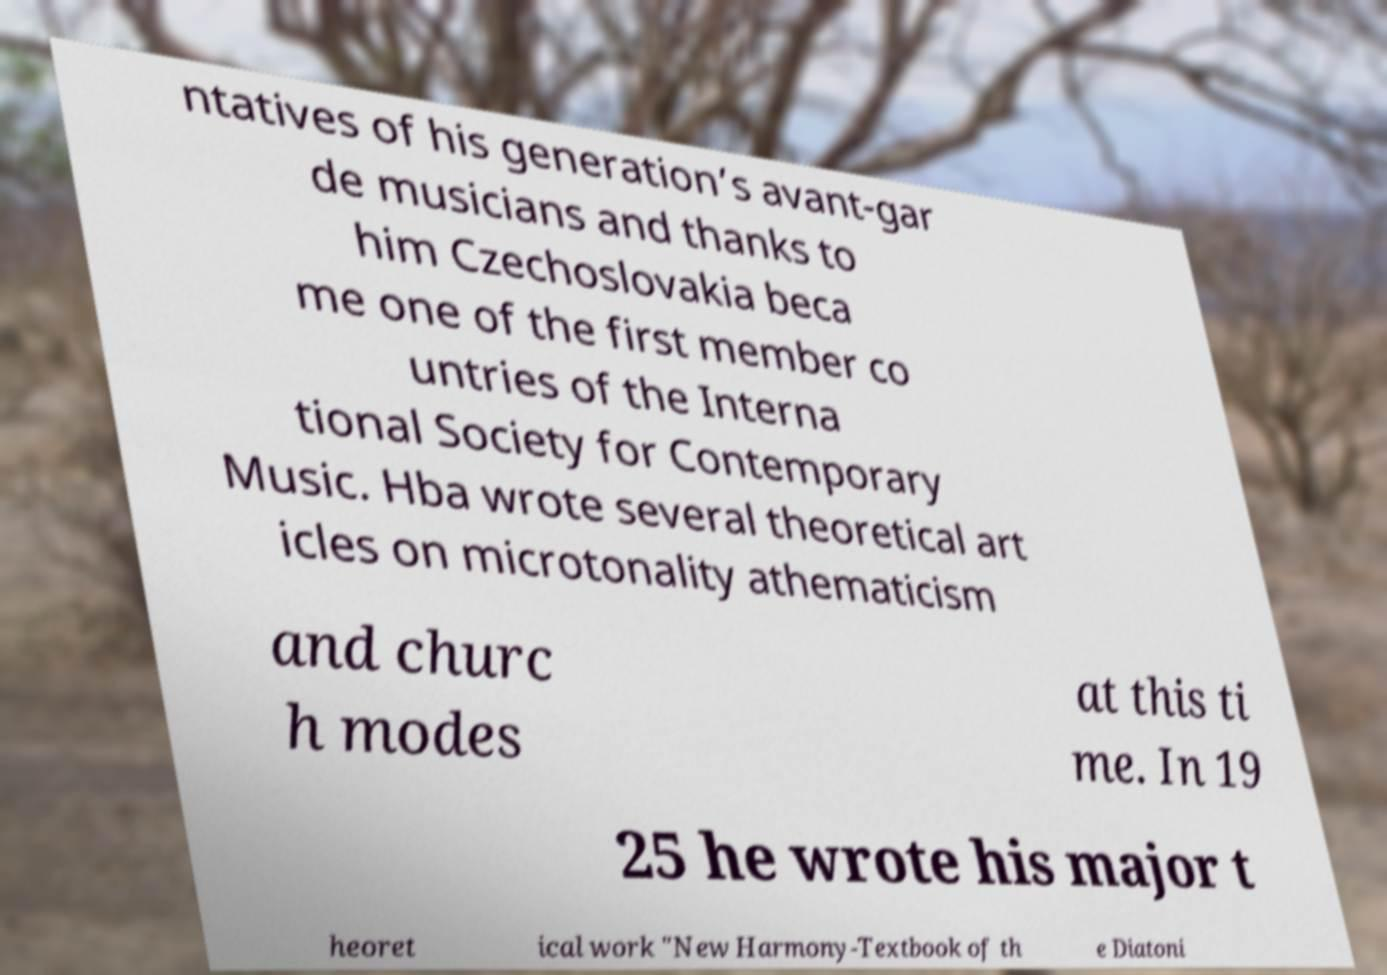What messages or text are displayed in this image? I need them in a readable, typed format. ntatives of his generation’s avant-gar de musicians and thanks to him Czechoslovakia beca me one of the first member co untries of the Interna tional Society for Contemporary Music. Hba wrote several theoretical art icles on microtonality athematicism and churc h modes at this ti me. In 19 25 he wrote his major t heoret ical work "New Harmony-Textbook of th e Diatoni 